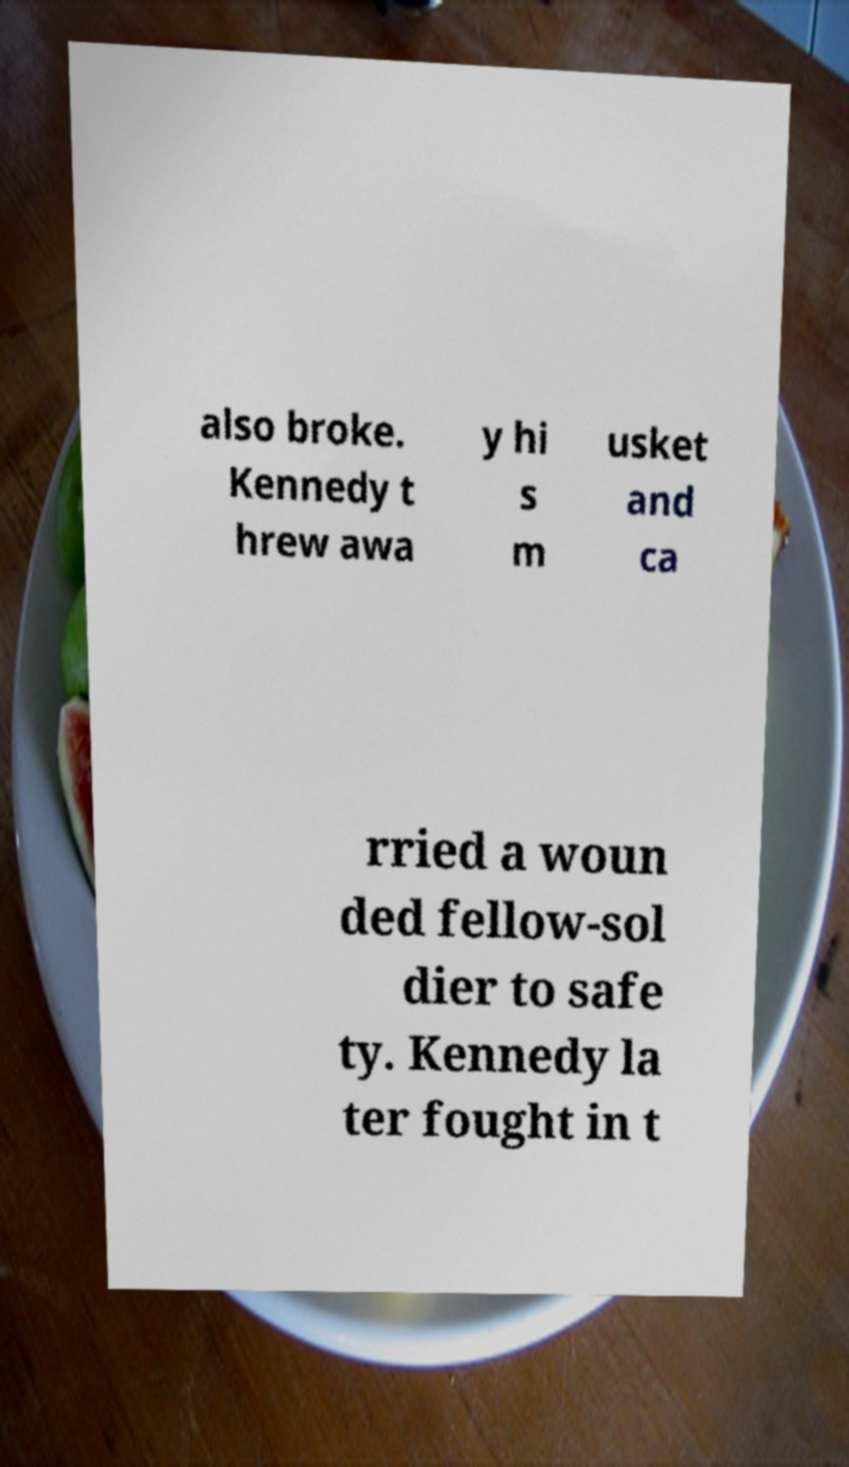Could you assist in decoding the text presented in this image and type it out clearly? also broke. Kennedy t hrew awa y hi s m usket and ca rried a woun ded fellow-sol dier to safe ty. Kennedy la ter fought in t 